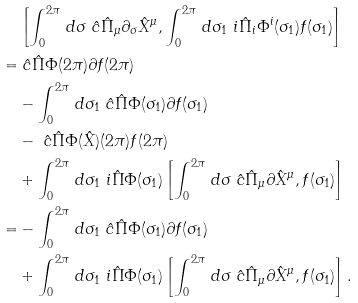Convert formula to latex. <formula><loc_0><loc_0><loc_500><loc_500>& \left [ \int _ { 0 } ^ { 2 \pi } \, d \sigma \ \hat { c } \hat { \Pi } _ { \mu } \partial _ { \sigma } \hat { X } ^ { \mu } , \int _ { 0 } ^ { 2 \pi } \, d \sigma _ { 1 } \ i \hat { \Pi } _ { i } \Phi ^ { i } ( \sigma _ { 1 } ) f ( \sigma _ { 1 } ) \right ] \\ = & \ \hat { c } \hat { \Pi } \Phi ( 2 \pi ) \partial f ( 2 \pi ) \\ & - \int _ { 0 } ^ { 2 \pi } \, d \sigma _ { 1 } \ \hat { c } \hat { \Pi } \Phi ( \sigma _ { 1 } ) \partial f ( \sigma _ { 1 } ) \\ & - \ \hat { c } \hat { \Pi } \Phi ( \hat { X } ) ( 2 \pi ) f ( 2 \pi ) \\ & + \int _ { 0 } ^ { 2 \pi } \, d \sigma _ { 1 } \ i \hat { \Pi } \Phi ( \sigma _ { 1 } ) \left [ \int _ { 0 } ^ { 2 \pi } \, d \sigma \ \hat { c } \hat { \Pi } _ { \mu } \partial \hat { X } ^ { \mu } , f ( \sigma _ { 1 } ) \right ] \\ = & - \int _ { 0 } ^ { 2 \pi } \, d \sigma _ { 1 } \ \hat { c } \hat { \Pi } \Phi ( \sigma _ { 1 } ) \partial f ( \sigma _ { 1 } ) \\ & + \int _ { 0 } ^ { 2 \pi } \, d \sigma _ { 1 } \ i \hat { \Pi } \Phi ( \sigma _ { 1 } ) \left [ \int _ { 0 } ^ { 2 \pi } \, d \sigma \ \hat { c } \hat { \Pi } _ { \mu } \partial \hat { X } ^ { \mu } , f ( \sigma _ { 1 } ) \right ] .</formula> 